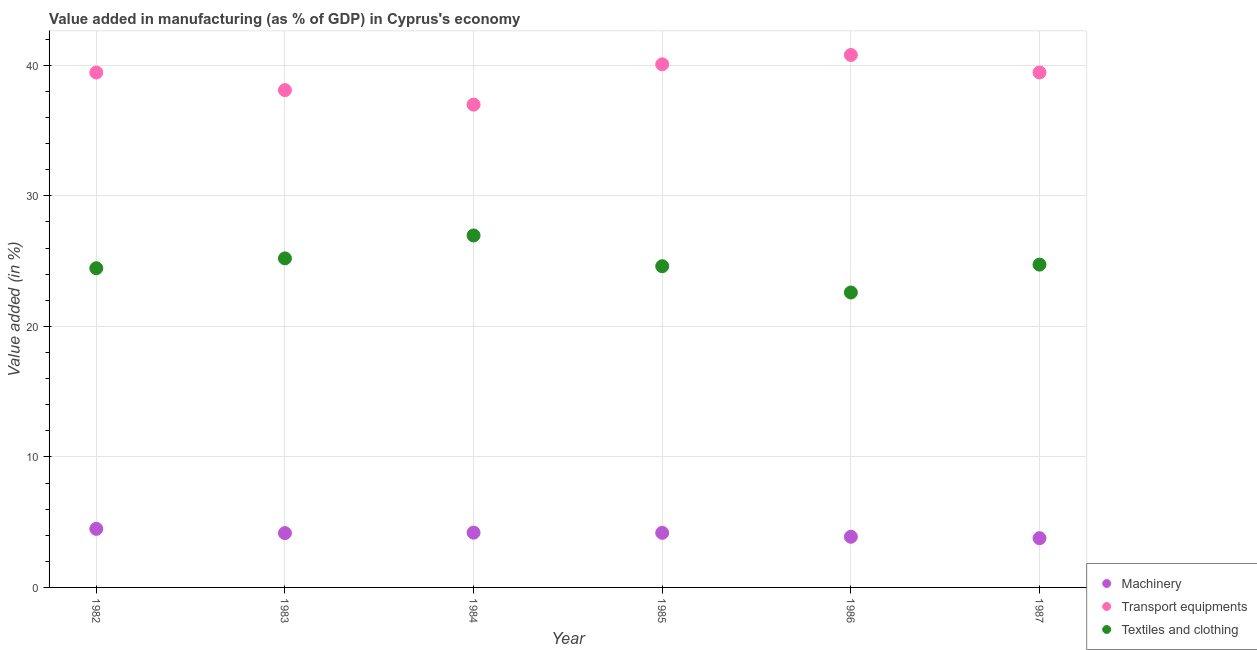What is the value added in manufacturing transport equipments in 1986?
Provide a short and direct response. 40.79. Across all years, what is the maximum value added in manufacturing machinery?
Make the answer very short. 4.49. Across all years, what is the minimum value added in manufacturing textile and clothing?
Offer a terse response. 22.6. What is the total value added in manufacturing textile and clothing in the graph?
Offer a terse response. 148.57. What is the difference between the value added in manufacturing machinery in 1982 and that in 1984?
Your answer should be compact. 0.29. What is the difference between the value added in manufacturing transport equipments in 1987 and the value added in manufacturing textile and clothing in 1984?
Ensure brevity in your answer.  12.49. What is the average value added in manufacturing transport equipments per year?
Make the answer very short. 39.15. In the year 1986, what is the difference between the value added in manufacturing transport equipments and value added in manufacturing textile and clothing?
Provide a succinct answer. 18.2. In how many years, is the value added in manufacturing textile and clothing greater than 26 %?
Your response must be concise. 1. What is the ratio of the value added in manufacturing textile and clothing in 1984 to that in 1986?
Offer a very short reply. 1.19. Is the value added in manufacturing machinery in 1983 less than that in 1984?
Provide a short and direct response. Yes. What is the difference between the highest and the second highest value added in manufacturing textile and clothing?
Your answer should be compact. 1.75. What is the difference between the highest and the lowest value added in manufacturing textile and clothing?
Your answer should be compact. 4.37. Is the sum of the value added in manufacturing machinery in 1985 and 1986 greater than the maximum value added in manufacturing transport equipments across all years?
Offer a terse response. No. Is it the case that in every year, the sum of the value added in manufacturing machinery and value added in manufacturing transport equipments is greater than the value added in manufacturing textile and clothing?
Give a very brief answer. Yes. Does the value added in manufacturing machinery monotonically increase over the years?
Provide a succinct answer. No. Is the value added in manufacturing machinery strictly greater than the value added in manufacturing transport equipments over the years?
Offer a very short reply. No. Is the value added in manufacturing transport equipments strictly less than the value added in manufacturing machinery over the years?
Make the answer very short. No. Does the graph contain grids?
Your answer should be compact. Yes. How many legend labels are there?
Provide a short and direct response. 3. What is the title of the graph?
Keep it short and to the point. Value added in manufacturing (as % of GDP) in Cyprus's economy. Does "Labor Market" appear as one of the legend labels in the graph?
Make the answer very short. No. What is the label or title of the X-axis?
Keep it short and to the point. Year. What is the label or title of the Y-axis?
Give a very brief answer. Value added (in %). What is the Value added (in %) of Machinery in 1982?
Offer a terse response. 4.49. What is the Value added (in %) of Transport equipments in 1982?
Provide a succinct answer. 39.45. What is the Value added (in %) of Textiles and clothing in 1982?
Offer a terse response. 24.46. What is the Value added (in %) of Machinery in 1983?
Your answer should be compact. 4.16. What is the Value added (in %) of Transport equipments in 1983?
Offer a terse response. 38.1. What is the Value added (in %) in Textiles and clothing in 1983?
Offer a terse response. 25.21. What is the Value added (in %) of Machinery in 1984?
Provide a succinct answer. 4.2. What is the Value added (in %) in Transport equipments in 1984?
Your answer should be compact. 36.99. What is the Value added (in %) of Textiles and clothing in 1984?
Ensure brevity in your answer.  26.96. What is the Value added (in %) in Machinery in 1985?
Provide a succinct answer. 4.18. What is the Value added (in %) of Transport equipments in 1985?
Ensure brevity in your answer.  40.08. What is the Value added (in %) in Textiles and clothing in 1985?
Your response must be concise. 24.61. What is the Value added (in %) of Machinery in 1986?
Offer a very short reply. 3.88. What is the Value added (in %) of Transport equipments in 1986?
Your answer should be compact. 40.79. What is the Value added (in %) in Textiles and clothing in 1986?
Provide a succinct answer. 22.6. What is the Value added (in %) of Machinery in 1987?
Give a very brief answer. 3.77. What is the Value added (in %) in Transport equipments in 1987?
Your answer should be very brief. 39.45. What is the Value added (in %) of Textiles and clothing in 1987?
Your answer should be very brief. 24.73. Across all years, what is the maximum Value added (in %) of Machinery?
Your answer should be very brief. 4.49. Across all years, what is the maximum Value added (in %) in Transport equipments?
Offer a very short reply. 40.79. Across all years, what is the maximum Value added (in %) in Textiles and clothing?
Your response must be concise. 26.96. Across all years, what is the minimum Value added (in %) of Machinery?
Your response must be concise. 3.77. Across all years, what is the minimum Value added (in %) in Transport equipments?
Provide a succinct answer. 36.99. Across all years, what is the minimum Value added (in %) in Textiles and clothing?
Keep it short and to the point. 22.6. What is the total Value added (in %) of Machinery in the graph?
Make the answer very short. 24.68. What is the total Value added (in %) of Transport equipments in the graph?
Offer a very short reply. 234.88. What is the total Value added (in %) of Textiles and clothing in the graph?
Give a very brief answer. 148.57. What is the difference between the Value added (in %) of Machinery in 1982 and that in 1983?
Ensure brevity in your answer.  0.33. What is the difference between the Value added (in %) of Transport equipments in 1982 and that in 1983?
Your answer should be compact. 1.35. What is the difference between the Value added (in %) in Textiles and clothing in 1982 and that in 1983?
Offer a very short reply. -0.75. What is the difference between the Value added (in %) in Machinery in 1982 and that in 1984?
Give a very brief answer. 0.29. What is the difference between the Value added (in %) in Transport equipments in 1982 and that in 1984?
Offer a terse response. 2.46. What is the difference between the Value added (in %) in Textiles and clothing in 1982 and that in 1984?
Keep it short and to the point. -2.51. What is the difference between the Value added (in %) of Machinery in 1982 and that in 1985?
Give a very brief answer. 0.31. What is the difference between the Value added (in %) in Transport equipments in 1982 and that in 1985?
Provide a succinct answer. -0.63. What is the difference between the Value added (in %) in Textiles and clothing in 1982 and that in 1985?
Give a very brief answer. -0.15. What is the difference between the Value added (in %) in Machinery in 1982 and that in 1986?
Offer a terse response. 0.61. What is the difference between the Value added (in %) in Transport equipments in 1982 and that in 1986?
Your answer should be compact. -1.34. What is the difference between the Value added (in %) in Textiles and clothing in 1982 and that in 1986?
Provide a succinct answer. 1.86. What is the difference between the Value added (in %) in Machinery in 1982 and that in 1987?
Your answer should be compact. 0.71. What is the difference between the Value added (in %) of Transport equipments in 1982 and that in 1987?
Make the answer very short. -0. What is the difference between the Value added (in %) in Textiles and clothing in 1982 and that in 1987?
Give a very brief answer. -0.28. What is the difference between the Value added (in %) of Machinery in 1983 and that in 1984?
Keep it short and to the point. -0.04. What is the difference between the Value added (in %) in Textiles and clothing in 1983 and that in 1984?
Make the answer very short. -1.75. What is the difference between the Value added (in %) of Machinery in 1983 and that in 1985?
Keep it short and to the point. -0.02. What is the difference between the Value added (in %) of Transport equipments in 1983 and that in 1985?
Provide a short and direct response. -1.98. What is the difference between the Value added (in %) in Textiles and clothing in 1983 and that in 1985?
Your answer should be compact. 0.6. What is the difference between the Value added (in %) of Machinery in 1983 and that in 1986?
Ensure brevity in your answer.  0.28. What is the difference between the Value added (in %) in Transport equipments in 1983 and that in 1986?
Provide a succinct answer. -2.69. What is the difference between the Value added (in %) in Textiles and clothing in 1983 and that in 1986?
Ensure brevity in your answer.  2.61. What is the difference between the Value added (in %) of Machinery in 1983 and that in 1987?
Offer a very short reply. 0.39. What is the difference between the Value added (in %) of Transport equipments in 1983 and that in 1987?
Your answer should be very brief. -1.35. What is the difference between the Value added (in %) of Textiles and clothing in 1983 and that in 1987?
Keep it short and to the point. 0.48. What is the difference between the Value added (in %) in Machinery in 1984 and that in 1985?
Offer a terse response. 0.01. What is the difference between the Value added (in %) of Transport equipments in 1984 and that in 1985?
Offer a very short reply. -3.09. What is the difference between the Value added (in %) in Textiles and clothing in 1984 and that in 1985?
Give a very brief answer. 2.35. What is the difference between the Value added (in %) in Machinery in 1984 and that in 1986?
Offer a terse response. 0.31. What is the difference between the Value added (in %) of Transport equipments in 1984 and that in 1986?
Ensure brevity in your answer.  -3.8. What is the difference between the Value added (in %) in Textiles and clothing in 1984 and that in 1986?
Your response must be concise. 4.37. What is the difference between the Value added (in %) of Machinery in 1984 and that in 1987?
Provide a succinct answer. 0.42. What is the difference between the Value added (in %) in Transport equipments in 1984 and that in 1987?
Keep it short and to the point. -2.46. What is the difference between the Value added (in %) of Textiles and clothing in 1984 and that in 1987?
Make the answer very short. 2.23. What is the difference between the Value added (in %) in Machinery in 1985 and that in 1986?
Make the answer very short. 0.3. What is the difference between the Value added (in %) in Transport equipments in 1985 and that in 1986?
Provide a short and direct response. -0.71. What is the difference between the Value added (in %) in Textiles and clothing in 1985 and that in 1986?
Offer a very short reply. 2.01. What is the difference between the Value added (in %) in Machinery in 1985 and that in 1987?
Give a very brief answer. 0.41. What is the difference between the Value added (in %) of Transport equipments in 1985 and that in 1987?
Make the answer very short. 0.63. What is the difference between the Value added (in %) in Textiles and clothing in 1985 and that in 1987?
Provide a short and direct response. -0.12. What is the difference between the Value added (in %) of Machinery in 1986 and that in 1987?
Offer a terse response. 0.11. What is the difference between the Value added (in %) in Transport equipments in 1986 and that in 1987?
Your response must be concise. 1.34. What is the difference between the Value added (in %) of Textiles and clothing in 1986 and that in 1987?
Provide a succinct answer. -2.14. What is the difference between the Value added (in %) of Machinery in 1982 and the Value added (in %) of Transport equipments in 1983?
Give a very brief answer. -33.62. What is the difference between the Value added (in %) in Machinery in 1982 and the Value added (in %) in Textiles and clothing in 1983?
Keep it short and to the point. -20.72. What is the difference between the Value added (in %) in Transport equipments in 1982 and the Value added (in %) in Textiles and clothing in 1983?
Offer a terse response. 14.24. What is the difference between the Value added (in %) in Machinery in 1982 and the Value added (in %) in Transport equipments in 1984?
Your response must be concise. -32.5. What is the difference between the Value added (in %) of Machinery in 1982 and the Value added (in %) of Textiles and clothing in 1984?
Your answer should be compact. -22.48. What is the difference between the Value added (in %) in Transport equipments in 1982 and the Value added (in %) in Textiles and clothing in 1984?
Keep it short and to the point. 12.49. What is the difference between the Value added (in %) of Machinery in 1982 and the Value added (in %) of Transport equipments in 1985?
Your response must be concise. -35.59. What is the difference between the Value added (in %) of Machinery in 1982 and the Value added (in %) of Textiles and clothing in 1985?
Give a very brief answer. -20.12. What is the difference between the Value added (in %) of Transport equipments in 1982 and the Value added (in %) of Textiles and clothing in 1985?
Make the answer very short. 14.84. What is the difference between the Value added (in %) in Machinery in 1982 and the Value added (in %) in Transport equipments in 1986?
Your response must be concise. -36.31. What is the difference between the Value added (in %) in Machinery in 1982 and the Value added (in %) in Textiles and clothing in 1986?
Ensure brevity in your answer.  -18.11. What is the difference between the Value added (in %) in Transport equipments in 1982 and the Value added (in %) in Textiles and clothing in 1986?
Your answer should be very brief. 16.85. What is the difference between the Value added (in %) of Machinery in 1982 and the Value added (in %) of Transport equipments in 1987?
Provide a short and direct response. -34.97. What is the difference between the Value added (in %) in Machinery in 1982 and the Value added (in %) in Textiles and clothing in 1987?
Give a very brief answer. -20.25. What is the difference between the Value added (in %) in Transport equipments in 1982 and the Value added (in %) in Textiles and clothing in 1987?
Offer a very short reply. 14.72. What is the difference between the Value added (in %) in Machinery in 1983 and the Value added (in %) in Transport equipments in 1984?
Your answer should be compact. -32.83. What is the difference between the Value added (in %) of Machinery in 1983 and the Value added (in %) of Textiles and clothing in 1984?
Give a very brief answer. -22.8. What is the difference between the Value added (in %) in Transport equipments in 1983 and the Value added (in %) in Textiles and clothing in 1984?
Your answer should be compact. 11.14. What is the difference between the Value added (in %) of Machinery in 1983 and the Value added (in %) of Transport equipments in 1985?
Give a very brief answer. -35.92. What is the difference between the Value added (in %) in Machinery in 1983 and the Value added (in %) in Textiles and clothing in 1985?
Provide a succinct answer. -20.45. What is the difference between the Value added (in %) in Transport equipments in 1983 and the Value added (in %) in Textiles and clothing in 1985?
Offer a terse response. 13.49. What is the difference between the Value added (in %) of Machinery in 1983 and the Value added (in %) of Transport equipments in 1986?
Your answer should be very brief. -36.63. What is the difference between the Value added (in %) in Machinery in 1983 and the Value added (in %) in Textiles and clothing in 1986?
Provide a succinct answer. -18.44. What is the difference between the Value added (in %) in Transport equipments in 1983 and the Value added (in %) in Textiles and clothing in 1986?
Your answer should be compact. 15.51. What is the difference between the Value added (in %) of Machinery in 1983 and the Value added (in %) of Transport equipments in 1987?
Give a very brief answer. -35.29. What is the difference between the Value added (in %) of Machinery in 1983 and the Value added (in %) of Textiles and clothing in 1987?
Your answer should be compact. -20.57. What is the difference between the Value added (in %) of Transport equipments in 1983 and the Value added (in %) of Textiles and clothing in 1987?
Give a very brief answer. 13.37. What is the difference between the Value added (in %) of Machinery in 1984 and the Value added (in %) of Transport equipments in 1985?
Provide a short and direct response. -35.88. What is the difference between the Value added (in %) in Machinery in 1984 and the Value added (in %) in Textiles and clothing in 1985?
Your response must be concise. -20.41. What is the difference between the Value added (in %) in Transport equipments in 1984 and the Value added (in %) in Textiles and clothing in 1985?
Provide a succinct answer. 12.38. What is the difference between the Value added (in %) of Machinery in 1984 and the Value added (in %) of Transport equipments in 1986?
Provide a short and direct response. -36.6. What is the difference between the Value added (in %) in Machinery in 1984 and the Value added (in %) in Textiles and clothing in 1986?
Make the answer very short. -18.4. What is the difference between the Value added (in %) in Transport equipments in 1984 and the Value added (in %) in Textiles and clothing in 1986?
Provide a succinct answer. 14.4. What is the difference between the Value added (in %) in Machinery in 1984 and the Value added (in %) in Transport equipments in 1987?
Offer a very short reply. -35.26. What is the difference between the Value added (in %) of Machinery in 1984 and the Value added (in %) of Textiles and clothing in 1987?
Offer a terse response. -20.54. What is the difference between the Value added (in %) in Transport equipments in 1984 and the Value added (in %) in Textiles and clothing in 1987?
Provide a succinct answer. 12.26. What is the difference between the Value added (in %) in Machinery in 1985 and the Value added (in %) in Transport equipments in 1986?
Provide a short and direct response. -36.61. What is the difference between the Value added (in %) of Machinery in 1985 and the Value added (in %) of Textiles and clothing in 1986?
Offer a very short reply. -18.41. What is the difference between the Value added (in %) in Transport equipments in 1985 and the Value added (in %) in Textiles and clothing in 1986?
Provide a short and direct response. 17.48. What is the difference between the Value added (in %) of Machinery in 1985 and the Value added (in %) of Transport equipments in 1987?
Ensure brevity in your answer.  -35.27. What is the difference between the Value added (in %) of Machinery in 1985 and the Value added (in %) of Textiles and clothing in 1987?
Offer a terse response. -20.55. What is the difference between the Value added (in %) of Transport equipments in 1985 and the Value added (in %) of Textiles and clothing in 1987?
Your answer should be compact. 15.35. What is the difference between the Value added (in %) in Machinery in 1986 and the Value added (in %) in Transport equipments in 1987?
Your answer should be compact. -35.57. What is the difference between the Value added (in %) of Machinery in 1986 and the Value added (in %) of Textiles and clothing in 1987?
Offer a terse response. -20.85. What is the difference between the Value added (in %) of Transport equipments in 1986 and the Value added (in %) of Textiles and clothing in 1987?
Make the answer very short. 16.06. What is the average Value added (in %) in Machinery per year?
Offer a very short reply. 4.11. What is the average Value added (in %) in Transport equipments per year?
Ensure brevity in your answer.  39.15. What is the average Value added (in %) of Textiles and clothing per year?
Give a very brief answer. 24.76. In the year 1982, what is the difference between the Value added (in %) in Machinery and Value added (in %) in Transport equipments?
Provide a succinct answer. -34.96. In the year 1982, what is the difference between the Value added (in %) of Machinery and Value added (in %) of Textiles and clothing?
Offer a terse response. -19.97. In the year 1982, what is the difference between the Value added (in %) in Transport equipments and Value added (in %) in Textiles and clothing?
Provide a succinct answer. 14.99. In the year 1983, what is the difference between the Value added (in %) of Machinery and Value added (in %) of Transport equipments?
Offer a very short reply. -33.94. In the year 1983, what is the difference between the Value added (in %) of Machinery and Value added (in %) of Textiles and clothing?
Your answer should be compact. -21.05. In the year 1983, what is the difference between the Value added (in %) of Transport equipments and Value added (in %) of Textiles and clothing?
Provide a succinct answer. 12.89. In the year 1984, what is the difference between the Value added (in %) in Machinery and Value added (in %) in Transport equipments?
Give a very brief answer. -32.8. In the year 1984, what is the difference between the Value added (in %) in Machinery and Value added (in %) in Textiles and clothing?
Your answer should be compact. -22.77. In the year 1984, what is the difference between the Value added (in %) in Transport equipments and Value added (in %) in Textiles and clothing?
Provide a succinct answer. 10.03. In the year 1985, what is the difference between the Value added (in %) in Machinery and Value added (in %) in Transport equipments?
Give a very brief answer. -35.9. In the year 1985, what is the difference between the Value added (in %) of Machinery and Value added (in %) of Textiles and clothing?
Ensure brevity in your answer.  -20.43. In the year 1985, what is the difference between the Value added (in %) of Transport equipments and Value added (in %) of Textiles and clothing?
Ensure brevity in your answer.  15.47. In the year 1986, what is the difference between the Value added (in %) of Machinery and Value added (in %) of Transport equipments?
Give a very brief answer. -36.91. In the year 1986, what is the difference between the Value added (in %) of Machinery and Value added (in %) of Textiles and clothing?
Offer a very short reply. -18.71. In the year 1986, what is the difference between the Value added (in %) of Transport equipments and Value added (in %) of Textiles and clothing?
Keep it short and to the point. 18.2. In the year 1987, what is the difference between the Value added (in %) of Machinery and Value added (in %) of Transport equipments?
Make the answer very short. -35.68. In the year 1987, what is the difference between the Value added (in %) in Machinery and Value added (in %) in Textiles and clothing?
Offer a very short reply. -20.96. In the year 1987, what is the difference between the Value added (in %) in Transport equipments and Value added (in %) in Textiles and clothing?
Offer a very short reply. 14.72. What is the ratio of the Value added (in %) in Machinery in 1982 to that in 1983?
Your response must be concise. 1.08. What is the ratio of the Value added (in %) of Transport equipments in 1982 to that in 1983?
Provide a short and direct response. 1.04. What is the ratio of the Value added (in %) in Textiles and clothing in 1982 to that in 1983?
Give a very brief answer. 0.97. What is the ratio of the Value added (in %) in Machinery in 1982 to that in 1984?
Your answer should be very brief. 1.07. What is the ratio of the Value added (in %) of Transport equipments in 1982 to that in 1984?
Keep it short and to the point. 1.07. What is the ratio of the Value added (in %) in Textiles and clothing in 1982 to that in 1984?
Your answer should be very brief. 0.91. What is the ratio of the Value added (in %) of Machinery in 1982 to that in 1985?
Give a very brief answer. 1.07. What is the ratio of the Value added (in %) in Transport equipments in 1982 to that in 1985?
Your response must be concise. 0.98. What is the ratio of the Value added (in %) in Machinery in 1982 to that in 1986?
Your response must be concise. 1.16. What is the ratio of the Value added (in %) in Transport equipments in 1982 to that in 1986?
Ensure brevity in your answer.  0.97. What is the ratio of the Value added (in %) in Textiles and clothing in 1982 to that in 1986?
Offer a very short reply. 1.08. What is the ratio of the Value added (in %) in Machinery in 1982 to that in 1987?
Your response must be concise. 1.19. What is the ratio of the Value added (in %) in Textiles and clothing in 1982 to that in 1987?
Make the answer very short. 0.99. What is the ratio of the Value added (in %) of Textiles and clothing in 1983 to that in 1984?
Offer a terse response. 0.93. What is the ratio of the Value added (in %) in Machinery in 1983 to that in 1985?
Provide a succinct answer. 1. What is the ratio of the Value added (in %) of Transport equipments in 1983 to that in 1985?
Ensure brevity in your answer.  0.95. What is the ratio of the Value added (in %) of Textiles and clothing in 1983 to that in 1985?
Provide a short and direct response. 1.02. What is the ratio of the Value added (in %) in Machinery in 1983 to that in 1986?
Offer a terse response. 1.07. What is the ratio of the Value added (in %) of Transport equipments in 1983 to that in 1986?
Keep it short and to the point. 0.93. What is the ratio of the Value added (in %) in Textiles and clothing in 1983 to that in 1986?
Keep it short and to the point. 1.12. What is the ratio of the Value added (in %) of Machinery in 1983 to that in 1987?
Provide a short and direct response. 1.1. What is the ratio of the Value added (in %) in Transport equipments in 1983 to that in 1987?
Offer a terse response. 0.97. What is the ratio of the Value added (in %) in Textiles and clothing in 1983 to that in 1987?
Offer a terse response. 1.02. What is the ratio of the Value added (in %) of Machinery in 1984 to that in 1985?
Your response must be concise. 1. What is the ratio of the Value added (in %) of Transport equipments in 1984 to that in 1985?
Give a very brief answer. 0.92. What is the ratio of the Value added (in %) in Textiles and clothing in 1984 to that in 1985?
Give a very brief answer. 1.1. What is the ratio of the Value added (in %) in Machinery in 1984 to that in 1986?
Provide a succinct answer. 1.08. What is the ratio of the Value added (in %) of Transport equipments in 1984 to that in 1986?
Make the answer very short. 0.91. What is the ratio of the Value added (in %) in Textiles and clothing in 1984 to that in 1986?
Provide a short and direct response. 1.19. What is the ratio of the Value added (in %) in Machinery in 1984 to that in 1987?
Offer a terse response. 1.11. What is the ratio of the Value added (in %) in Transport equipments in 1984 to that in 1987?
Ensure brevity in your answer.  0.94. What is the ratio of the Value added (in %) in Textiles and clothing in 1984 to that in 1987?
Make the answer very short. 1.09. What is the ratio of the Value added (in %) in Machinery in 1985 to that in 1986?
Provide a short and direct response. 1.08. What is the ratio of the Value added (in %) in Transport equipments in 1985 to that in 1986?
Ensure brevity in your answer.  0.98. What is the ratio of the Value added (in %) in Textiles and clothing in 1985 to that in 1986?
Keep it short and to the point. 1.09. What is the ratio of the Value added (in %) of Machinery in 1985 to that in 1987?
Your answer should be compact. 1.11. What is the ratio of the Value added (in %) of Transport equipments in 1985 to that in 1987?
Ensure brevity in your answer.  1.02. What is the ratio of the Value added (in %) of Textiles and clothing in 1985 to that in 1987?
Your answer should be compact. 0.99. What is the ratio of the Value added (in %) in Machinery in 1986 to that in 1987?
Your response must be concise. 1.03. What is the ratio of the Value added (in %) of Transport equipments in 1986 to that in 1987?
Offer a terse response. 1.03. What is the ratio of the Value added (in %) of Textiles and clothing in 1986 to that in 1987?
Give a very brief answer. 0.91. What is the difference between the highest and the second highest Value added (in %) in Machinery?
Ensure brevity in your answer.  0.29. What is the difference between the highest and the second highest Value added (in %) in Transport equipments?
Your answer should be compact. 0.71. What is the difference between the highest and the second highest Value added (in %) of Textiles and clothing?
Your answer should be compact. 1.75. What is the difference between the highest and the lowest Value added (in %) in Machinery?
Your response must be concise. 0.71. What is the difference between the highest and the lowest Value added (in %) in Transport equipments?
Your answer should be very brief. 3.8. What is the difference between the highest and the lowest Value added (in %) in Textiles and clothing?
Your answer should be compact. 4.37. 